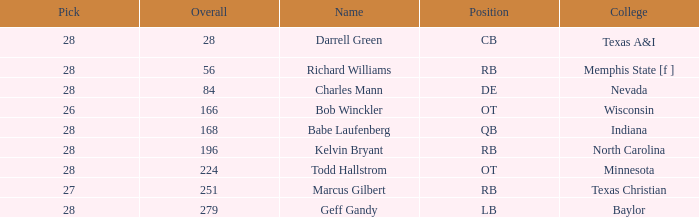What is the aggregate of the choice from texas a&i college with a round more than 1? None. 